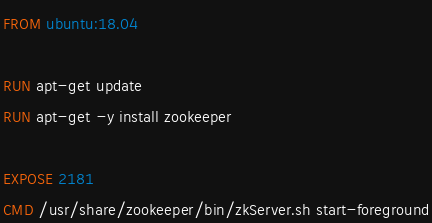<code> <loc_0><loc_0><loc_500><loc_500><_Dockerfile_>FROM ubuntu:18.04

RUN apt-get update
RUN apt-get -y install zookeeper

EXPOSE 2181
CMD /usr/share/zookeeper/bin/zkServer.sh start-foreground
</code> 